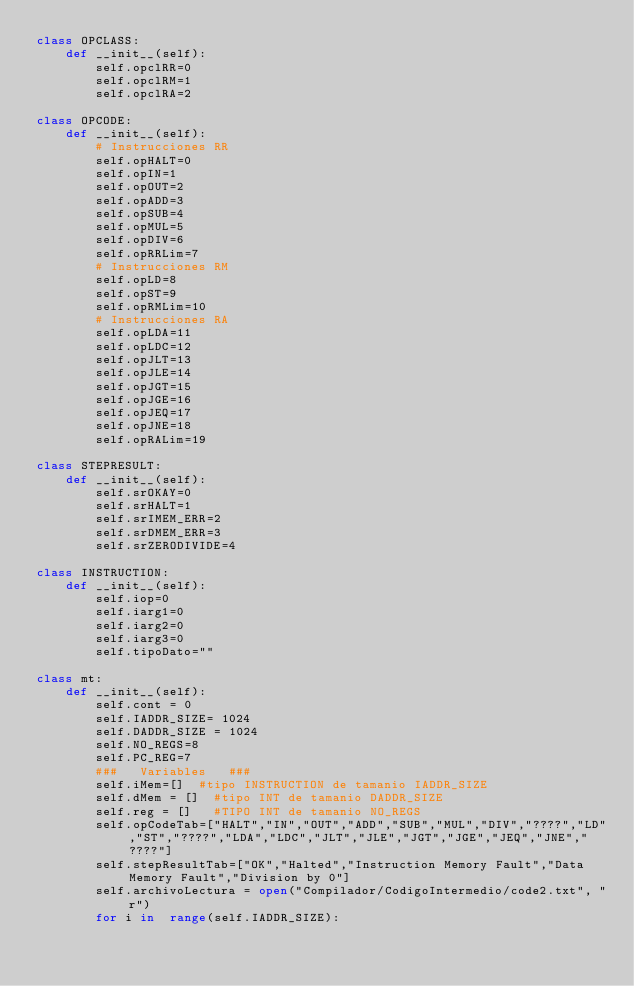<code> <loc_0><loc_0><loc_500><loc_500><_Python_>class OPCLASS:
    def __init__(self):
        self.opclRR=0
        self.opclRM=1
        self.opclRA=2

class OPCODE:
    def __init__(self):
        # Instrucciones RR
        self.opHALT=0
        self.opIN=1
        self.opOUT=2
        self.opADD=3
        self.opSUB=4
        self.opMUL=5
        self.opDIV=6
        self.opRRLim=7
        # Instrucciones RM
        self.opLD=8
        self.opST=9
        self.opRMLim=10
        # Instrucciones RA
        self.opLDA=11
        self.opLDC=12
        self.opJLT=13
        self.opJLE=14
        self.opJGT=15
        self.opJGE=16
        self.opJEQ=17
        self.opJNE=18
        self.opRALim=19

class STEPRESULT:
    def __init__(self):
        self.srOKAY=0
        self.srHALT=1
        self.srIMEM_ERR=2
        self.srDMEM_ERR=3
        self.srZERODIVIDE=4

class INSTRUCTION:
    def __init__(self):
        self.iop=0
        self.iarg1=0
        self.iarg2=0
        self.iarg3=0
        self.tipoDato=""

class mt:
    def __init__(self):
        self.cont = 0
        self.IADDR_SIZE= 1024
        self.DADDR_SIZE = 1024
        self.NO_REGS=8
        self.PC_REG=7
        ###   Variables   ###
        self.iMem=[]  #tipo INSTRUCTION de tamanio IADDR_SIZE
        self.dMem = []  #tipo INT de tamanio DADDR_SIZE
        self.reg = []   #TIPO INT de tamanio NO_REGS
        self.opCodeTab=["HALT","IN","OUT","ADD","SUB","MUL","DIV","????","LD","ST","????","LDA","LDC","JLT","JLE","JGT","JGE","JEQ","JNE","????"]
        self.stepResultTab=["OK","Halted","Instruction Memory Fault","Data Memory Fault","Division by 0"]
        self.archivoLectura = open("Compilador/CodigoIntermedio/code2.txt", "r")
        for i in  range(self.IADDR_SIZE):</code> 